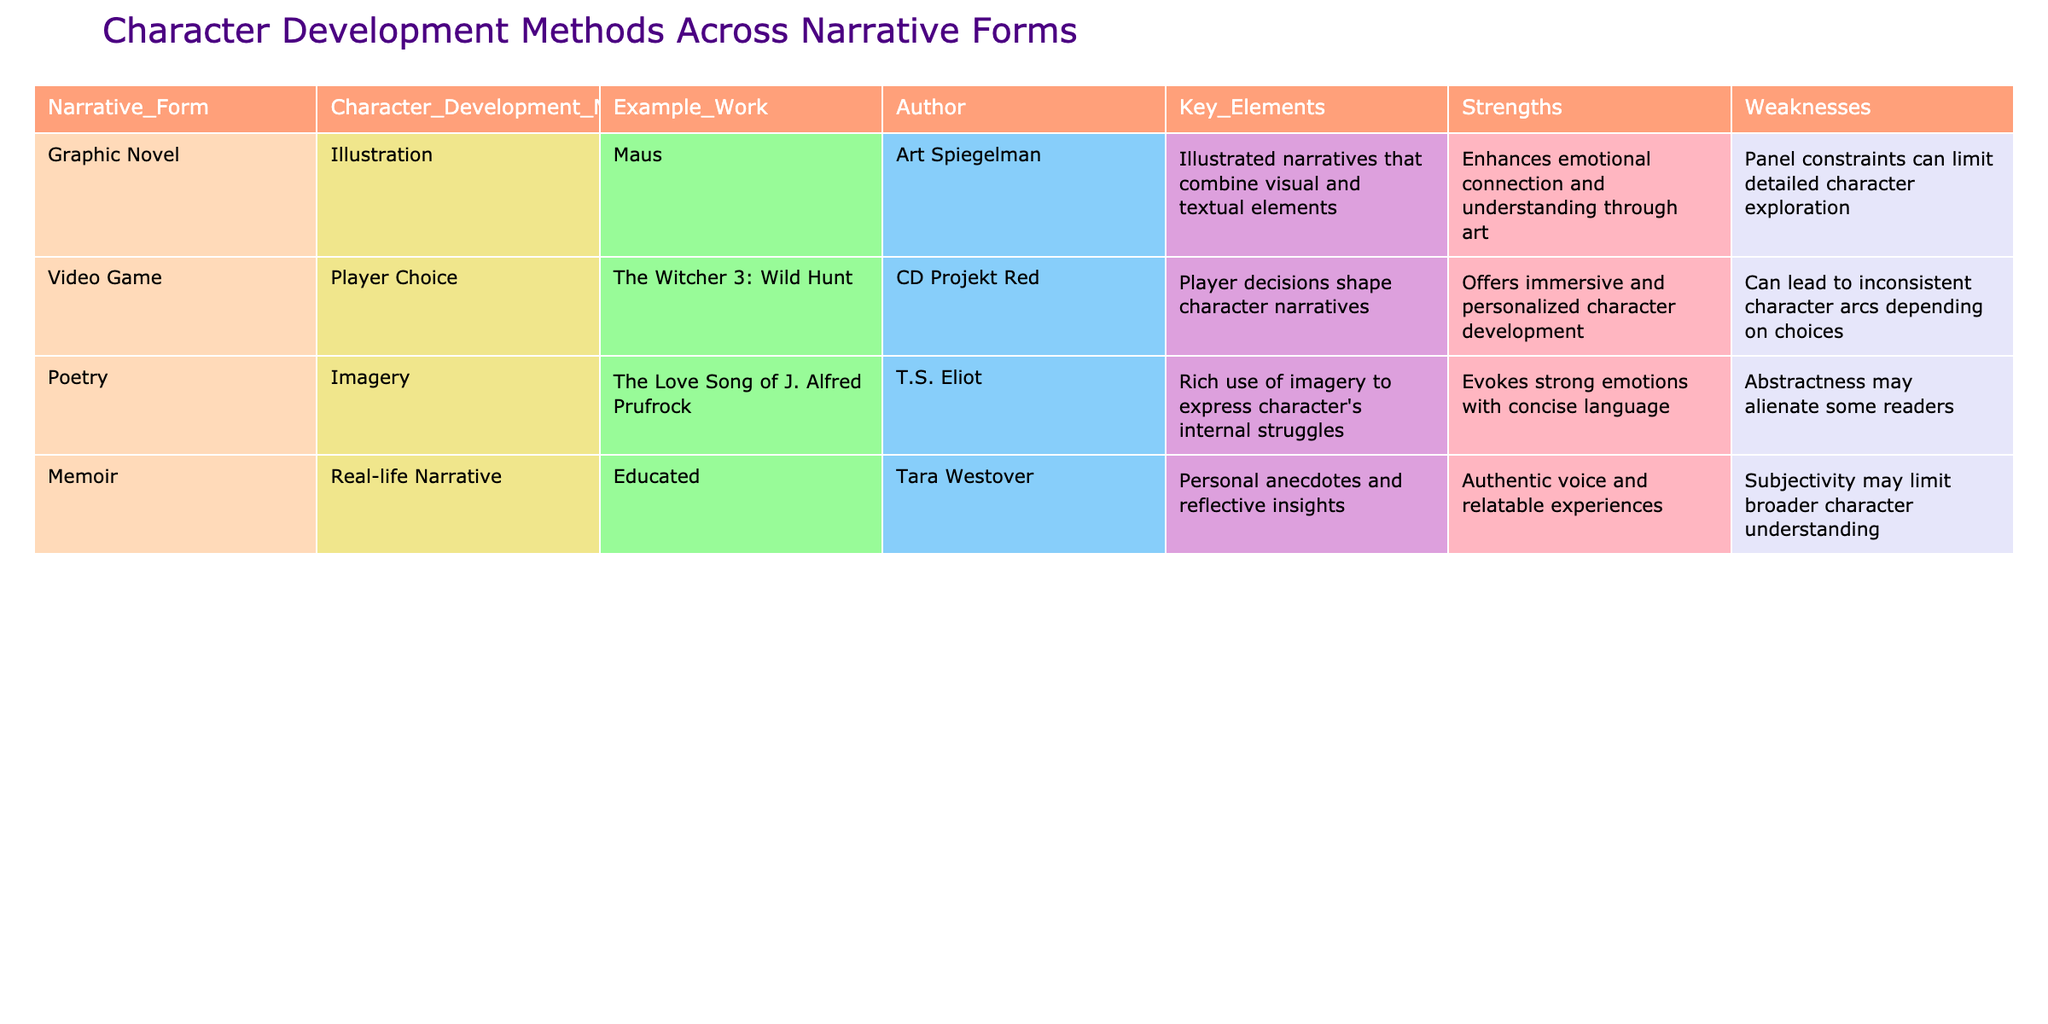What character development method is used in the graphic novel "Maus"? The table shows that the character development method used in "Maus" is illustration.
Answer: Illustration Which author wrote "The Love Song of J. Alfred Prufrock"? According to the table, the author of "The Love Song of J. Alfred Prufrock" is T.S. Eliot.
Answer: T.S. Eliot What are the strengths of real-life narrative in memoirs? The table lists that the strengths of real-life narratives in memoirs include an authentic voice and relatable experiences.
Answer: Authentic voice and relatable experiences Is player choice a method for character development in video games? Yes, the table states that player choice is indeed a method for character development in video games.
Answer: Yes Which narrative form has the example work "Educated"? The table indicates that "Educated" is a memoir.
Answer: Memoir What are the weaknesses of character development through poetry? The table mentions that the weaknesses of character development through poetry include abstractness, which may alienate some readers.
Answer: Abstractness may alienate some readers Which narrative form allows for immersive and personalized character development? The table specifies that video games, through player choice, allow for immersive and personalized character development.
Answer: Video games What is the key element of character development in "The Witcher 3: Wild Hunt"? The key element is that player decisions shape character narratives, according to the table.
Answer: Player decisions shape character narratives How many narrative forms are listed in the table? The table lists four narrative forms: graphic novel, video game, poetry, and memoir. Therefore, the total count is four.
Answer: Four If we compare the strengths of the graphic novel and memoir forms, what notable difference can be found? The graphic novel enhances emotional connection through art, while the memoir offers an authentic voice and relatable experiences. So, the notable difference is the emphasis on emotional connection versus authentic voice.
Answer: Emotional connection vs. authentic voice Which character development method has the most flexibility according to the strengths listed? Player choice in video games provides the most flexibility as it allows for immersive and personalized character development, more than the other methods.
Answer: Player choice in video games 